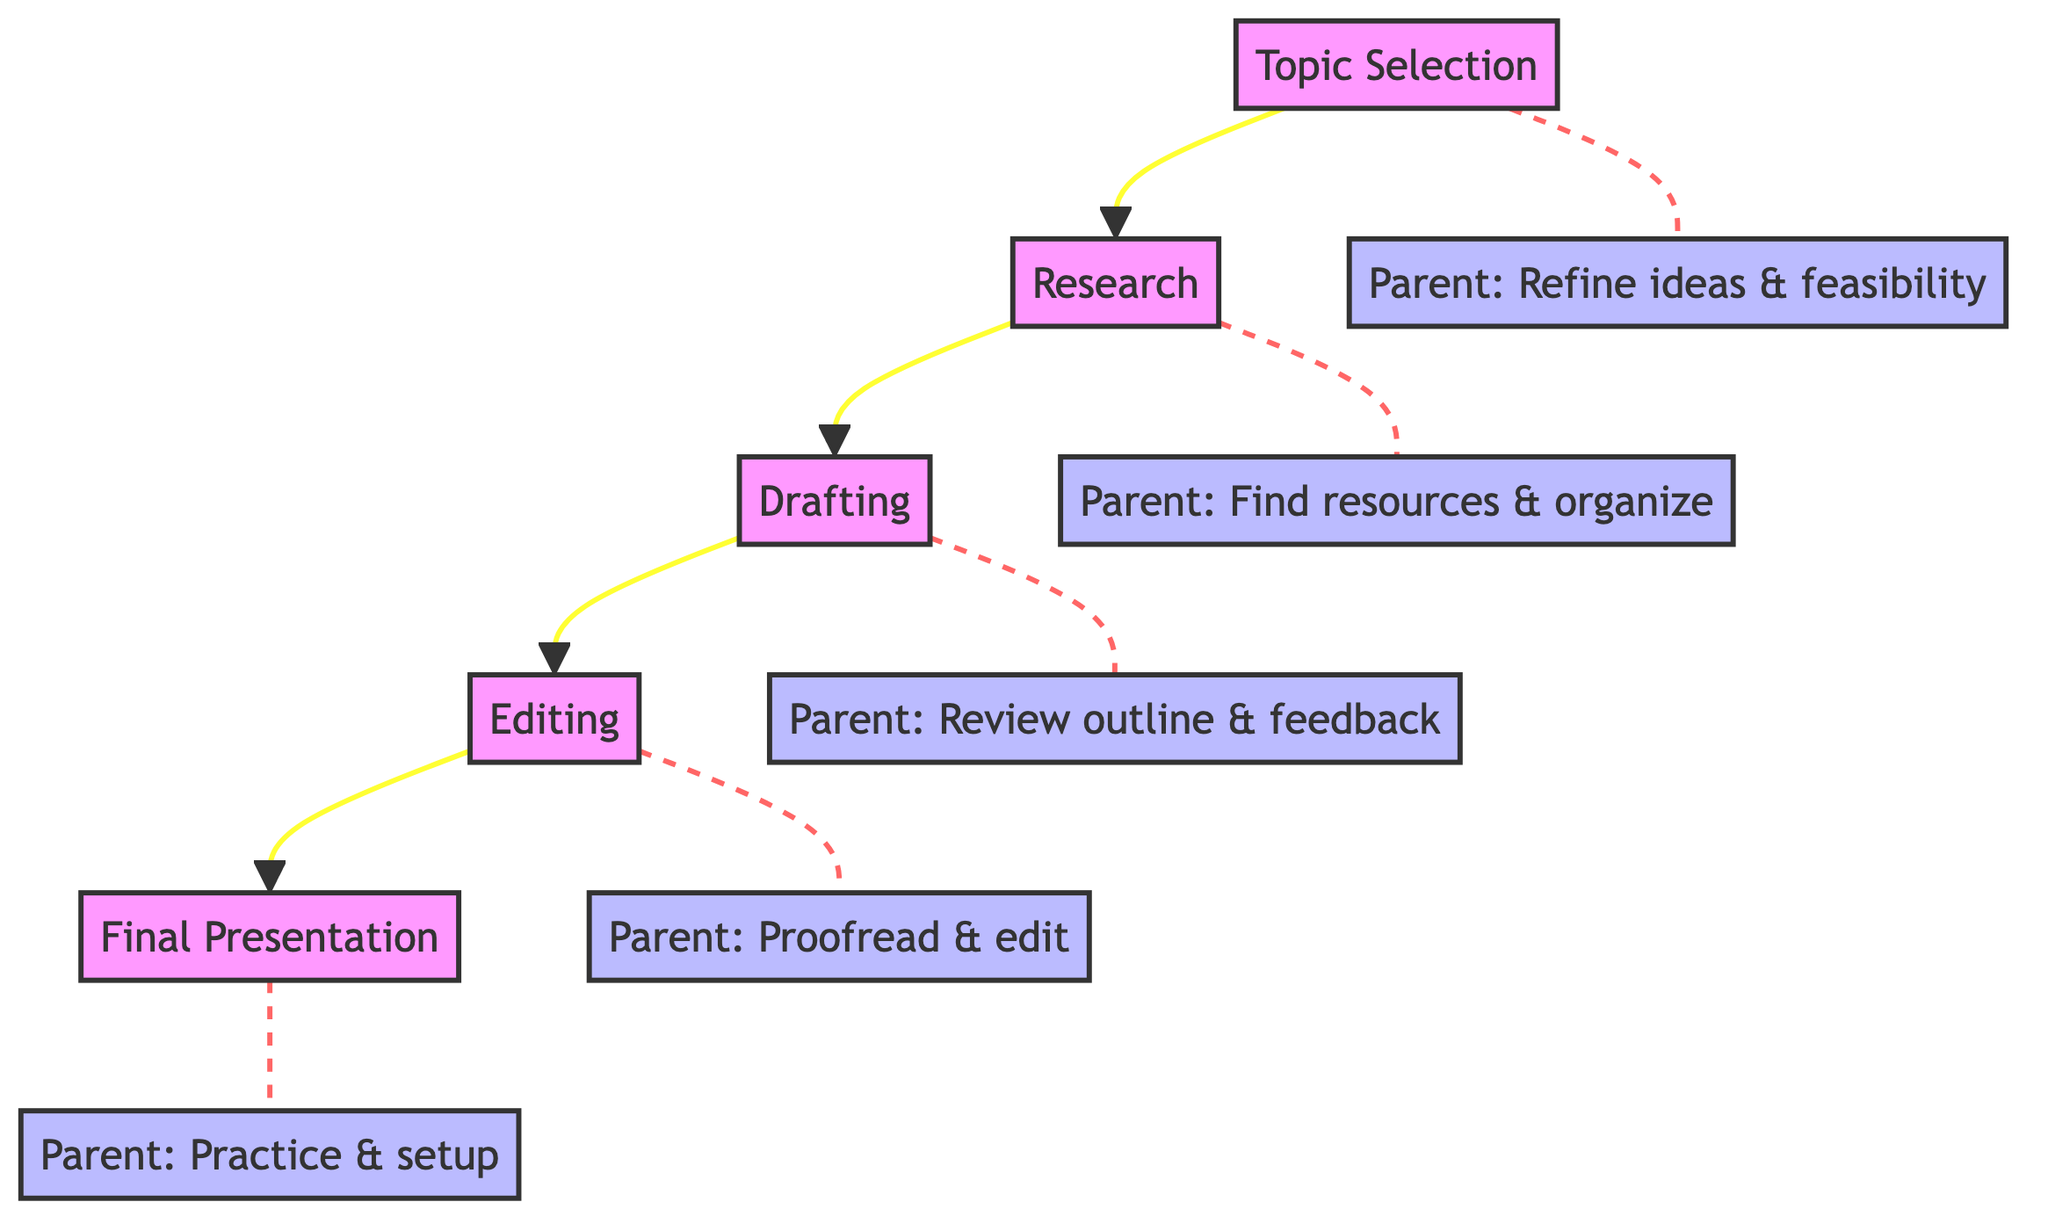What is the first step in the project completion process? According to the diagram, the flow begins with the block labeled "Topic Selection", indicating that this is step one in the project completion process.
Answer: Topic Selection How many steps are involved in completing the school project? The diagram outlines a total of five blocks/steps, which are all part of the project completion process.
Answer: 5 Which block follows the research step? The diagram shows that the "Drafting" step is directly connected to the "Research" block, indicating that it follows research in the sequence of steps.
Answer: Drafting What assistance does the parent provide during the editing step? The diagram identifies that during the "Editing" step, the parent helps in proofreading and editing the draft to ensure coherence and correctness.
Answer: Proofread & edit Name the common purpose of the steps in the diagram. The overall purpose of the steps in the diagram is to guide the completion of a school project in a structured manner.
Answer: Complete school project Which step involves creating visual aids? The final block labeled "Final Presentation" indicates that this step includes preparing the final report and creating visual aids if needed.
Answer: Final Presentation What type of connection is used to link the steps together in the diagram? The steps are connected by solid lines, indicating a direct flow from one step to the next.
Answer: Solid lines What does the parent assist with during the drafting step? In the "Drafting" step, the parent's involvement is to review the child's outline and provide feedback on the structure and content of the draft.
Answer: Review outline & feedback How is the involvement of the parent depicted in the diagram? The parent’s involvement is depicted as separate blocks connected to each step, showing their specific roles and support during the project completion process.
Answer: Separate blocks 